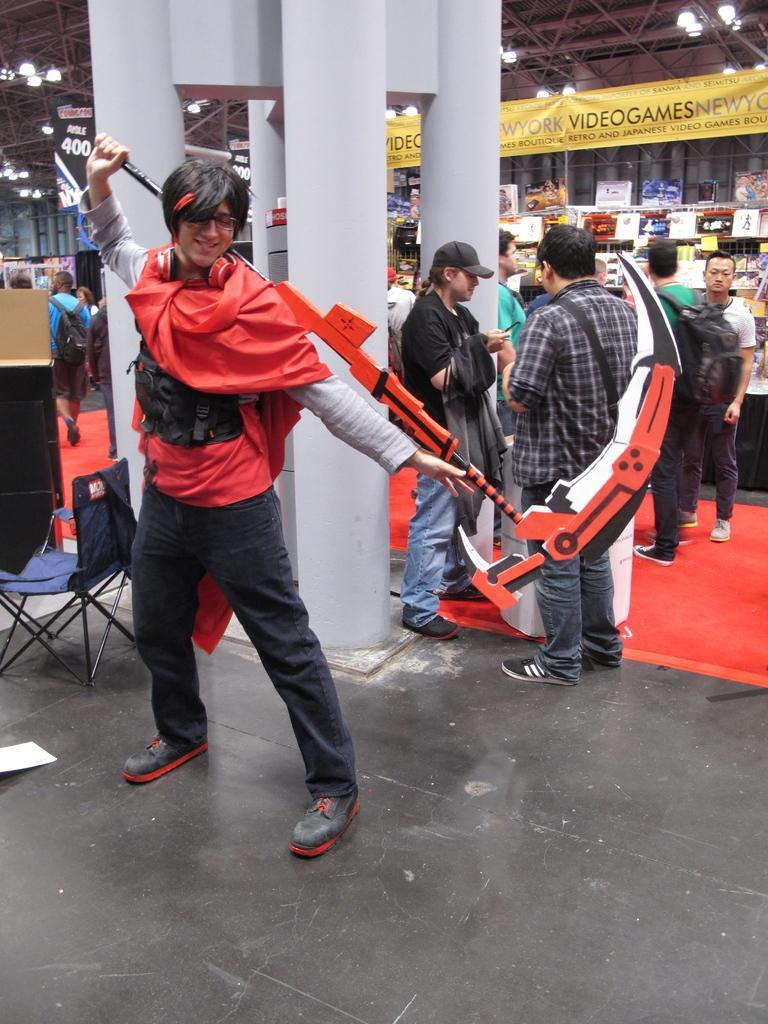In one or two sentences, can you explain what this image depicts? In this image I can see number of people are standing where in the front I can see one of them is wearing costume and holding a weapon. In the background I can see few of them are carrying bags. I can also see a chair on the left side and near it I can see four pillars. In the background I can see few boards, number of lights and on these boards I can see something is written. I can also see number of stuffs in the background. 